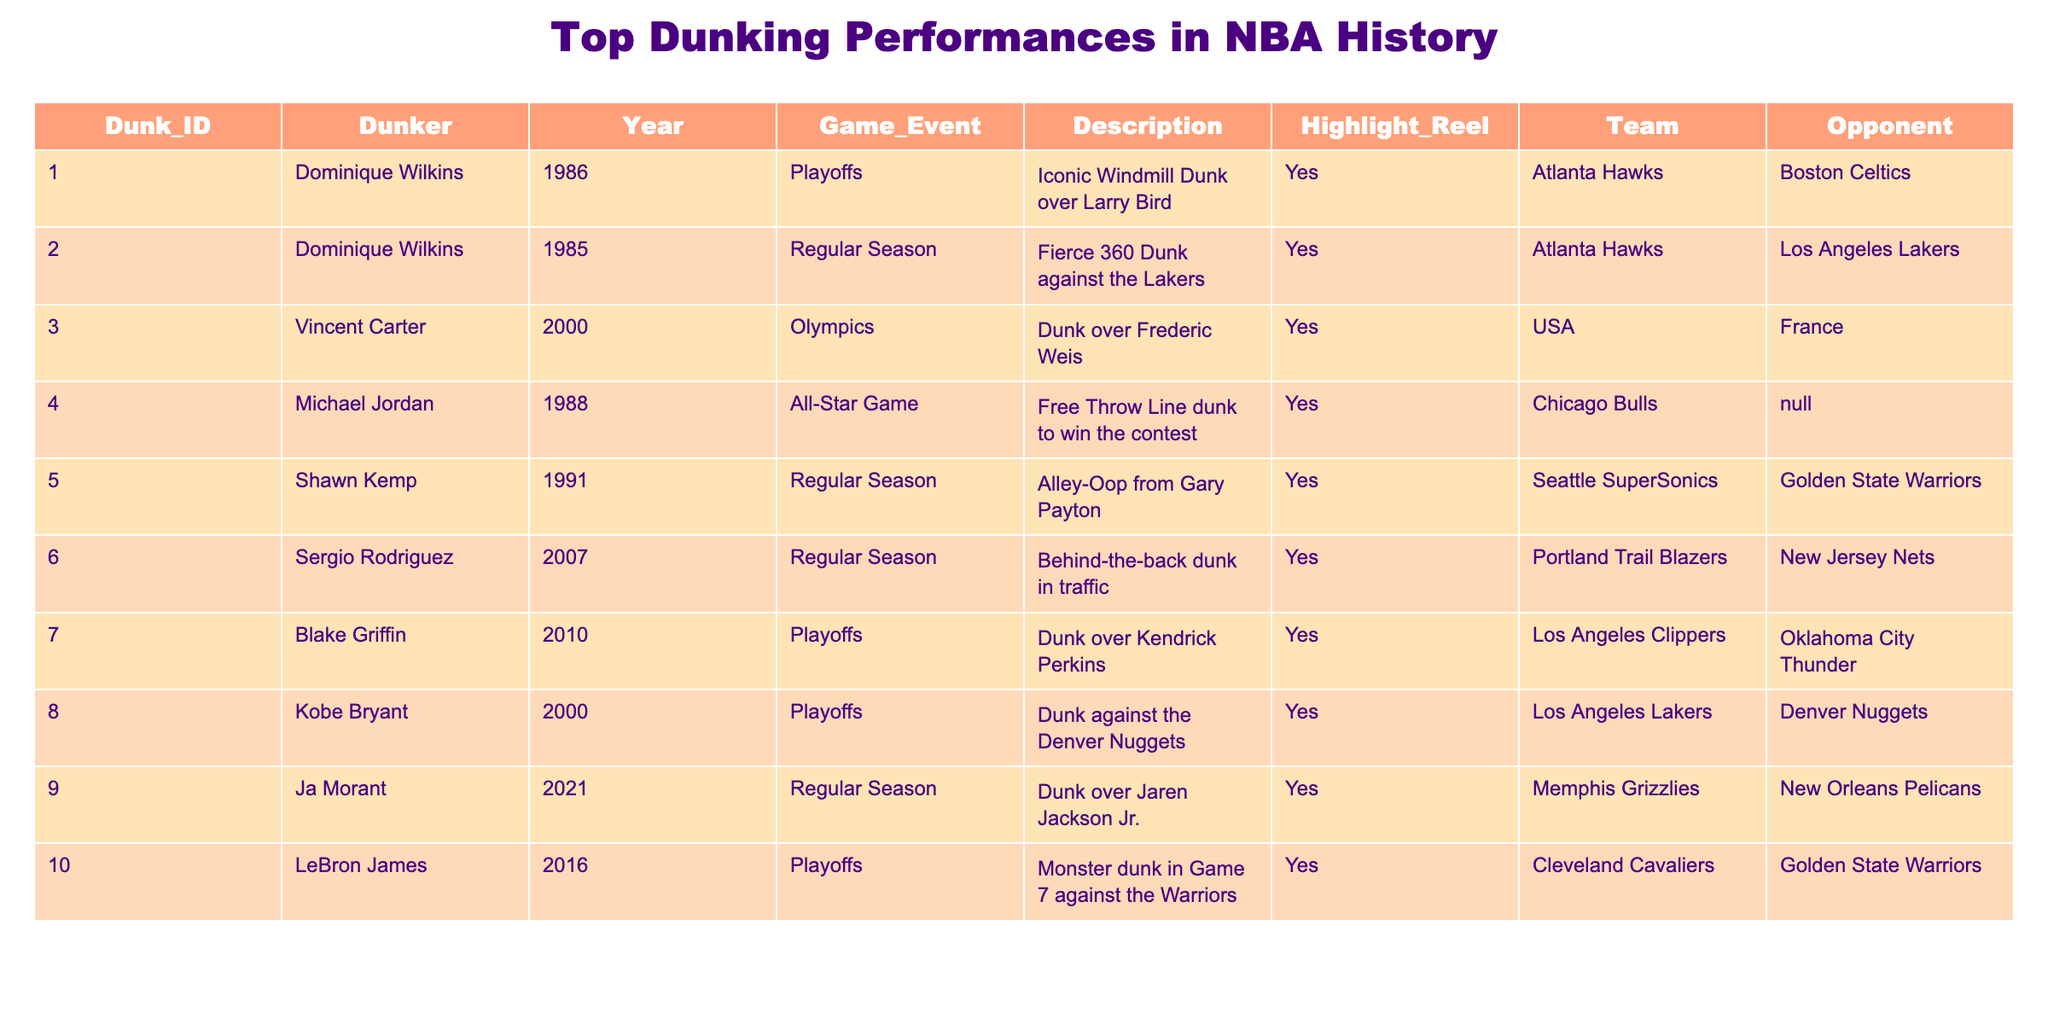What was the year of Dominique Wilkins' iconic dunk over Larry Bird? The table lists several dunks along with the corresponding year. By locating Dominique Wilkins in the table, I can see that his iconic windmill dunk over Larry Bird occurred in 1986.
Answer: 1986 How many dunk performances listed occurred in the playoffs? By reviewing the "Game_Event" column in the table and counting the occurrences of "Playoffs," I find that there are six dunk performances categorized as playoff events.
Answer: 6 Which dunker performed an impressive dunk in the 2000 Olympics? The table indicates that Vincent Carter had a dunk over Frederic Weis during the 2000 Olympics, according to the "Year" and "Game_Event" columns.
Answer: Vincent Carter Did Shawn Kemp's dunk occur during the regular season? By checking the "Game_Event" column for Shawn Kemp, it states that the dunk in question occurred during the regular season, which confirms that the statement is true.
Answer: Yes Who had the most recent dunk listed in the table? To determine this, I review the "Year" column and find that Ja Morant's dunk in 2021 is the most recent entry in the table, as it is later than all other years listed.
Answer: Ja Morant What was the average year of the highlighted dunks? To calculate the average year, I sum up all the years from the "Year" column: 1986 + 1985 + 2000 + 1988 + 1991 + 2007 + 2010 + 2000 + 2021 + 2016 = 199. The total number of performances is 10, so the average year is 1991.
Answer: 1991 How many dunk performances were performed by the Atlanta Hawks? By focusing on the "Team" column in the table, I count the occurrences of "Atlanta Hawks," which appears twice: for Dominique Wilkins' dunks in 1986 and 1985.
Answer: 2 Which team did LeBron James play against during his dunk in 2016? Referring to the "Opponent" column next to LeBron James' name, it states that his notable dunk in 2016 was against the Golden State Warriors.
Answer: Golden State Warriors Is there any dunk performance that was not part of a playoff, regular season, or an All-Star Game? By reviewing the "Game_Event" column, I note that all entries belong to either the playoffs or regular season; therefore, there are no dunk performances outside these classifications in the table.
Answer: No 